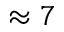<formula> <loc_0><loc_0><loc_500><loc_500>\approx 7</formula> 